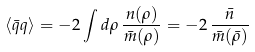Convert formula to latex. <formula><loc_0><loc_0><loc_500><loc_500>\langle \bar { q } q \rangle = - 2 \int d \rho \, \frac { n ( \rho ) } { \bar { m } ( \rho ) } = - 2 \, \frac { \bar { n } } { \bar { m } ( \bar { \rho } ) }</formula> 